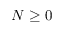Convert formula to latex. <formula><loc_0><loc_0><loc_500><loc_500>N \geq 0</formula> 